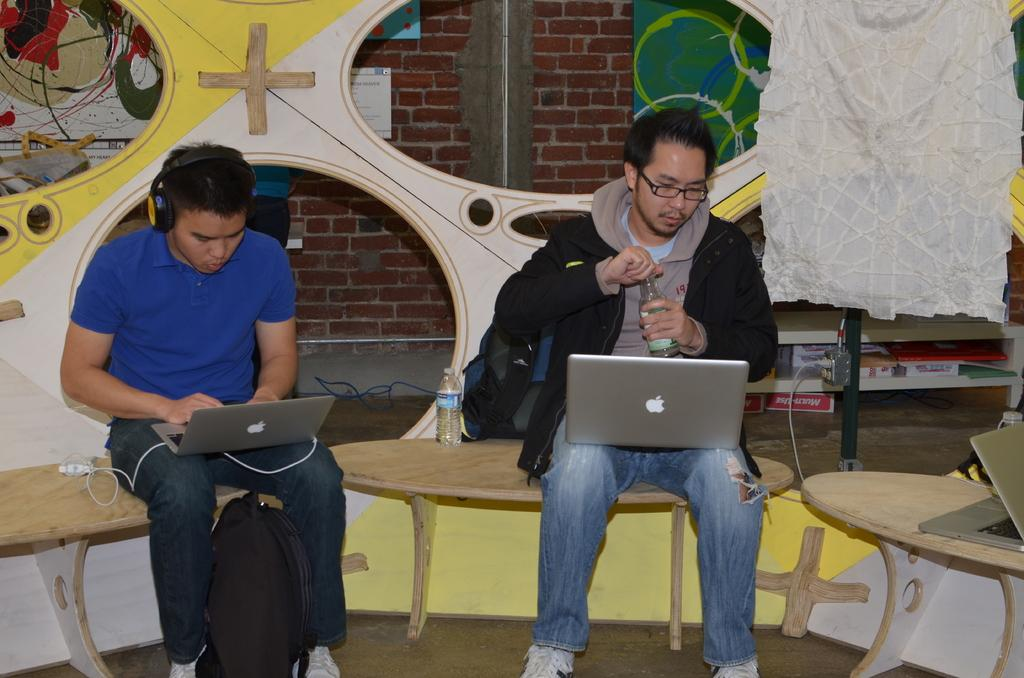What are the persons in the image doing? The persons in the image are sitting on a bench. What are they looking at while sitting on the bench? They are looking at a laptop. Can you describe the clothing of one of the persons? One person is wearing a sweater. What accessory is the person wearing while looking at the laptop? The person is wearing a headset. What type of can is visible in the image? There is no can present in the image. What type of collar can be seen on the person in the image? The person in the image is not wearing a collar; they are wearing a headset. 